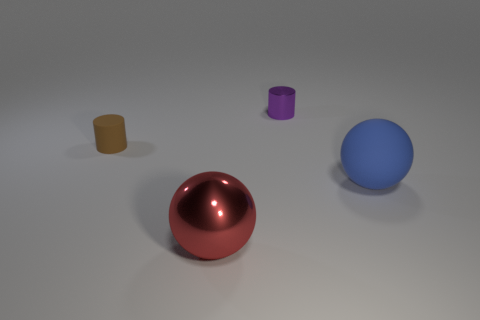Add 1 brown matte things. How many objects exist? 5 Subtract 0 brown balls. How many objects are left? 4 Subtract all tiny red metal blocks. Subtract all large red metallic objects. How many objects are left? 3 Add 2 big blue balls. How many big blue balls are left? 3 Add 2 big blue spheres. How many big blue spheres exist? 3 